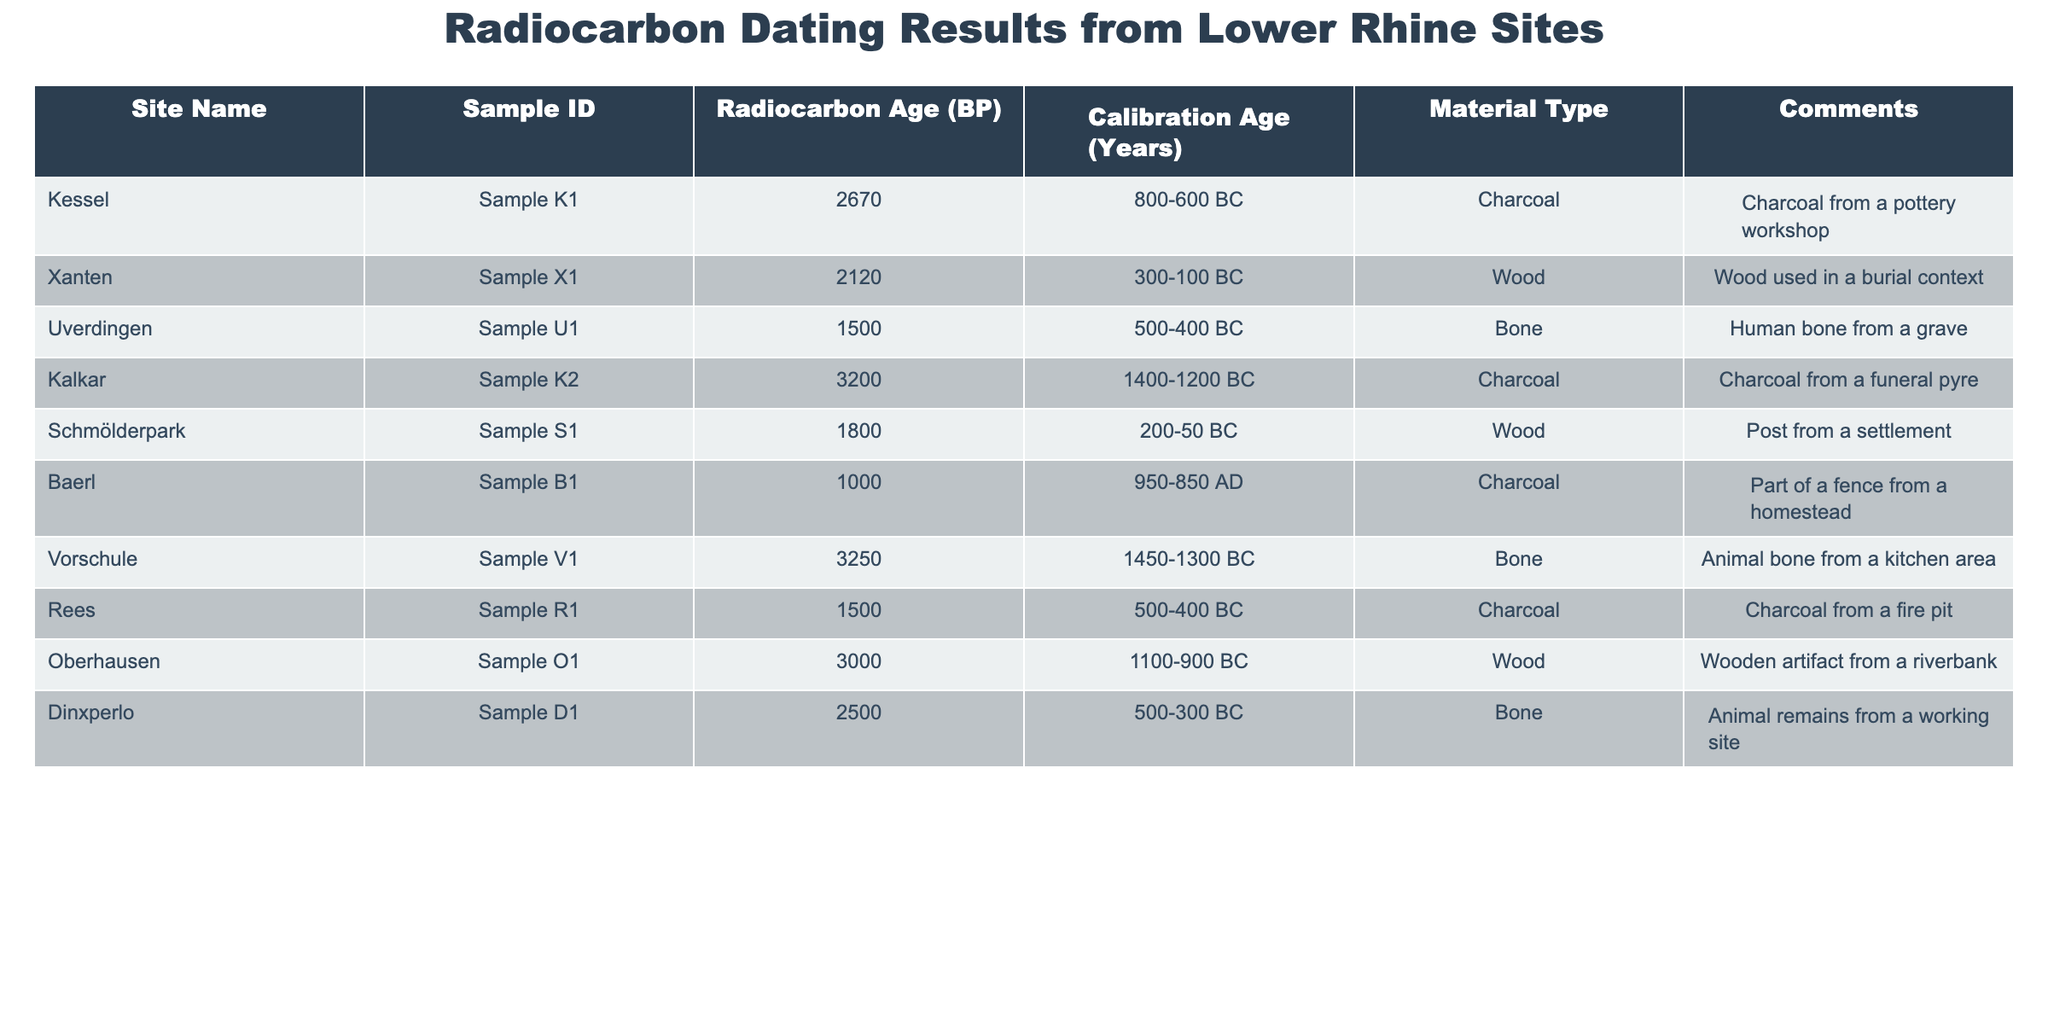What is the radiocarbon age of the sample from Xanten? The table shows the radiocarbon age of each sample. Looking for the entry corresponding to the site "Xanten," I find that its radiocarbon age is 2120 BP.
Answer: 2120 BP Which site has the oldest calibration age and what is that age? The calibration ages are listed alongside each site. The oldest calibration age in the table is 1450-1300 BC, which corresponds to the site "Vorschule."
Answer: Vorschule, 1450-1300 BC Is there any bone material found at the site of Uverdingen? The table specifies the material type for each site. It clearly states that the Uverdingen site has "Bone" as the material type.
Answer: Yes What is the average radiocarbon age of all the samples? To find the average, I sum up all the radiocarbon ages: 2670 + 2120 + 1500 + 3200 + 1800 + 1000 + 3250 + 1500 + 3000 + 2500 = 22,040. There are 10 samples, so the average is 22,040 / 10 = 2,204.
Answer: 2204 How many sites have a calibration age from the 1st millennium BC (i.e., 1000 BC to 1 AD)? I examine the calibration ages and identify those falling within the range of 1,000 BC to 1 AD, which are "300-100 BC," "200-50 BC," and "500-400 BC." These correspond to Xanten, Schmölderpark, and Uverdingen. There are 3 such sites.
Answer: 3 What material type is associated with the site of Kalkar? Referring to the table, I see that the material type listed for Kalkar is "Charcoal."
Answer: Charcoal Is the radiocarbon age for the sample from Baerl older than 1800 BP? The radiocarbon age for Baerl is 1000 BP. Comparing this value to 1800 BP indicates that 1000 is less than 1800.
Answer: No Which site has the most recent calibration age? The most recent calibration age is the latest one listed in the table, which is from Baerl, with a calibration age of 950-850 AD.
Answer: Baerl, 950-850 AD Calculate the difference in radiocarbon age between the oldest and youngest samples. The oldest radiocarbon age is from Kalkar at 3200 BP, and the youngest age is from Baerl at 1000 BP. The difference is 3200 - 1000 = 2200 BP.
Answer: 2200 BP What type of material is most frequently mentioned in the table? By examining the table, I see that both "Charcoal" and "Bone" appear multiple times. Charcoal appears four times, while Bone appears three times. Thus, "Charcoal" is the most frequently mentioned material type.
Answer: Charcoal 